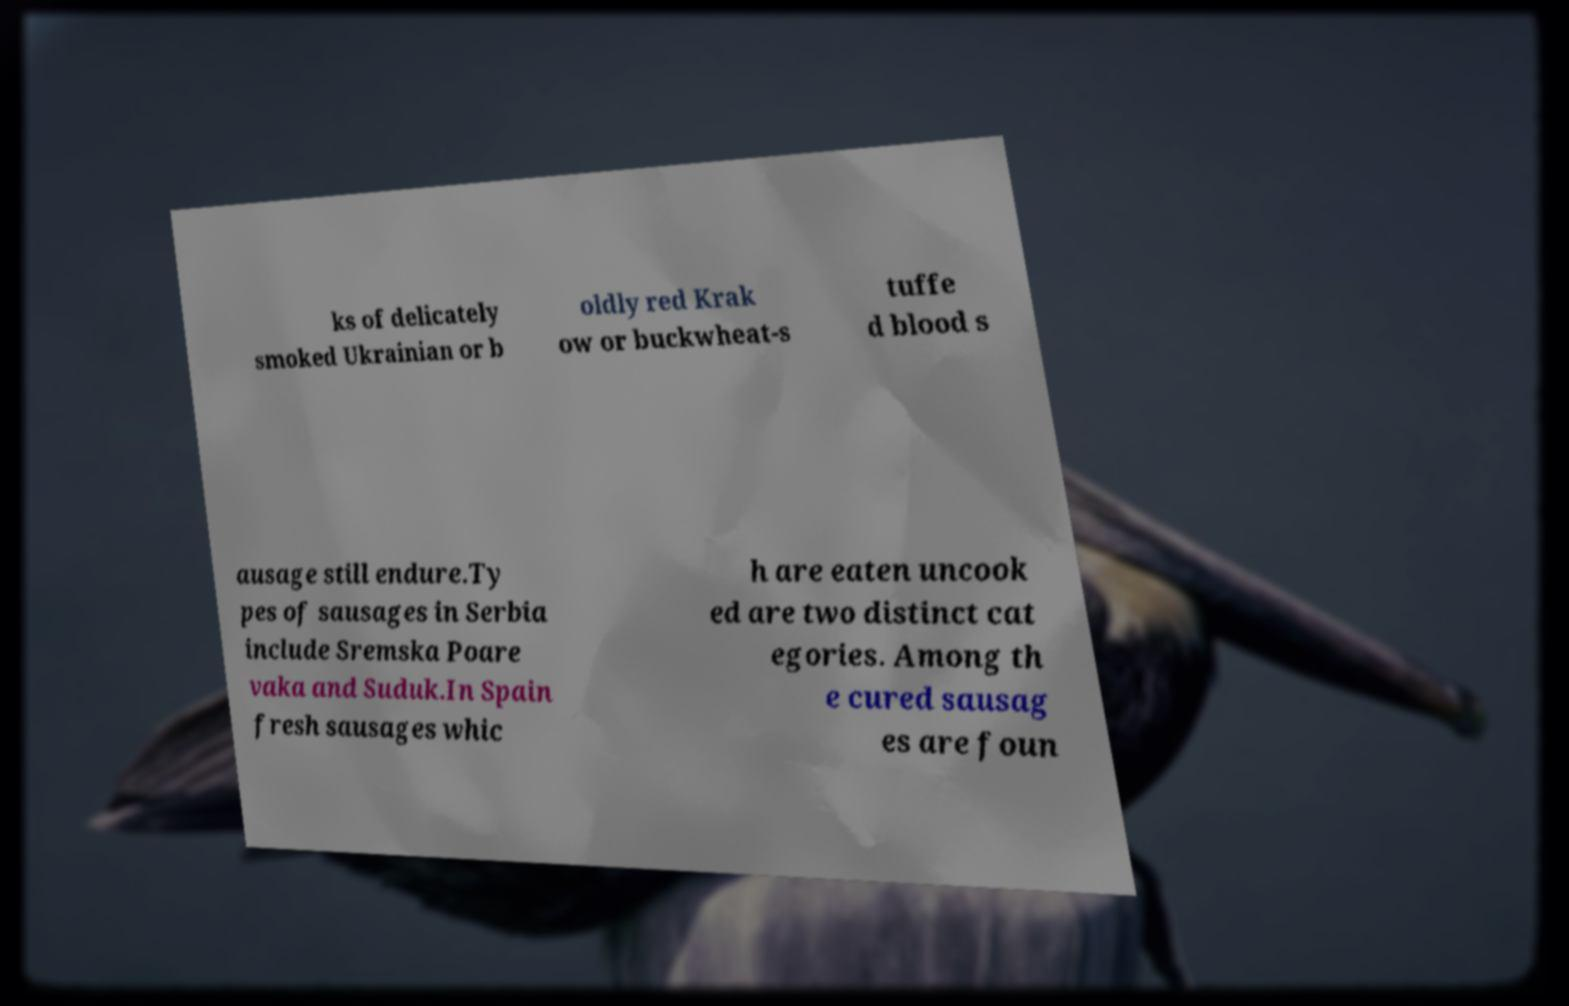Could you extract and type out the text from this image? ks of delicately smoked Ukrainian or b oldly red Krak ow or buckwheat-s tuffe d blood s ausage still endure.Ty pes of sausages in Serbia include Sremska Poare vaka and Suduk.In Spain fresh sausages whic h are eaten uncook ed are two distinct cat egories. Among th e cured sausag es are foun 